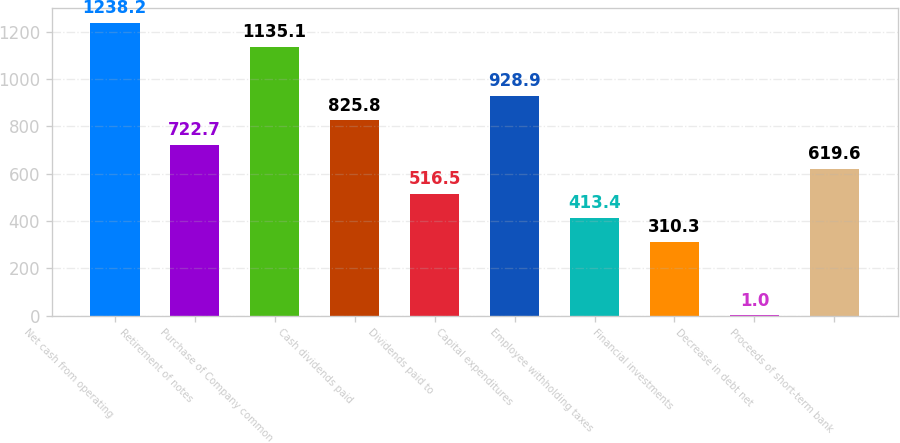<chart> <loc_0><loc_0><loc_500><loc_500><bar_chart><fcel>Net cash from operating<fcel>Retirement of notes<fcel>Purchase of Company common<fcel>Cash dividends paid<fcel>Dividends paid to<fcel>Capital expenditures<fcel>Employee withholding taxes<fcel>Financial investments<fcel>Decrease in debt net<fcel>Proceeds of short-term bank<nl><fcel>1238.2<fcel>722.7<fcel>1135.1<fcel>825.8<fcel>516.5<fcel>928.9<fcel>413.4<fcel>310.3<fcel>1<fcel>619.6<nl></chart> 